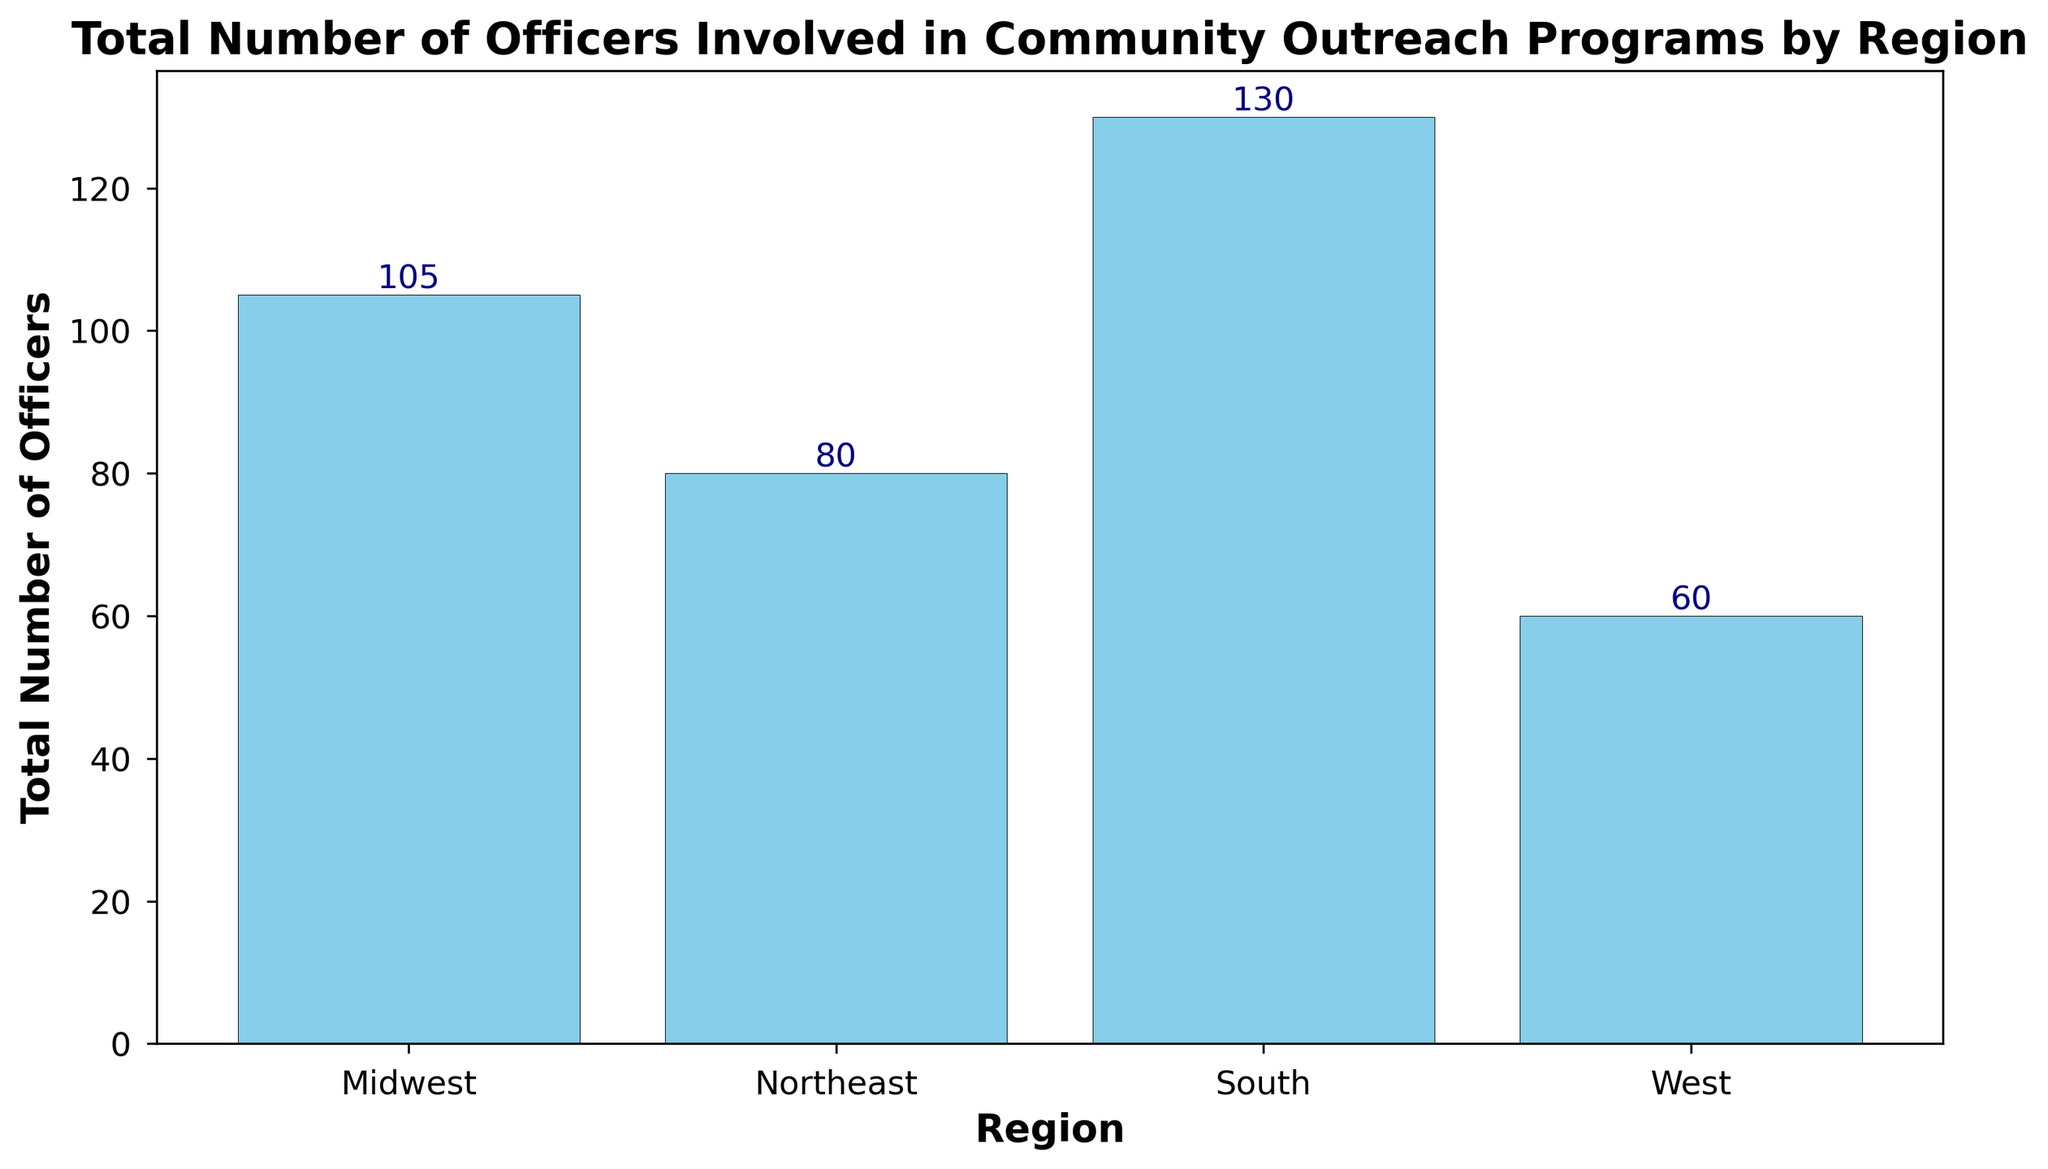Which region has the highest number of officers involved in community outreach programs? First, identify the bar with the highest value. The "South" bar is the tallest.
Answer: South Which region has the lowest number of officers involved in community outreach programs? Look for the smallest bar. The "West" bar is the shortest.
Answer: West What is the total number of officers involved in community outreach programs in the Northeast region? Sum the values of the bars for the Northeast region: 15 + 18 + 14 + 16 + 17 = 80.
Answer: 80 How many more officers are involved in community outreach programs in the South compared to the West? Sum the values for each region: South (25 + 28 + 24 + 26 + 27) = 130, West (10 + 12 + 11 + 13 + 14) = 60. The difference is 130 - 60.
Answer: 70 What is the average number of officers involved in community outreach programs in the Midwest region? Sum the values of the Midwest bars and divide by the number of bars: (20 + 22 + 19 + 21 + 23) / 5 = 21.
Answer: 21 Which region has the second highest total number of officers involved? Compare the total values: South = 130, Northeast = 80, Midwest = 105, West = 60. The Midwest is second.
Answer: Midwest What is the overall total number of officers involved across all regions? Sum all officers' values: South (130) + Northeast (80) + Midwest (105) + West (60) = 375.
Answer: 375 How much taller is the bar for the South region compared to the Northeast region? The South bar equals 130 and the Northeast bar equals 80. The height difference is 130 - 80.
Answer: 50 Is the number of officers in the Midwest region greater, less, or equal to the combined number of officers in the Northeast and West regions? Combine the totals for Northeast and West: 80 + 60 = 140. Compare it to Midwest (105). Midwest is less.
Answer: Less 